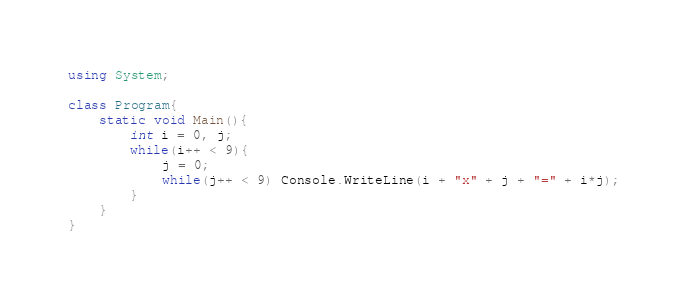Convert code to text. <code><loc_0><loc_0><loc_500><loc_500><_C#_>using System;
 
class Program{
    static void Main(){
        int i = 0, j;
        while(i++ < 9){
            j = 0;
            while(j++ < 9) Console.WriteLine(i + "x" + j + "=" + i*j);
        }
    }
}</code> 